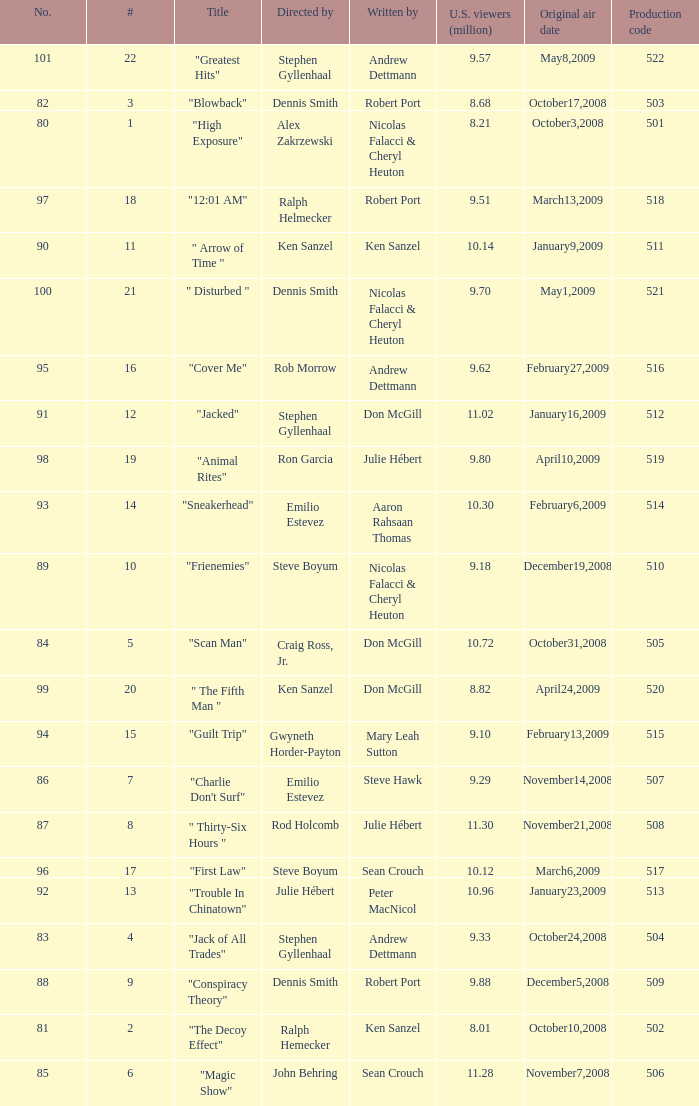How many times did episode 6 originally air? 1.0. 